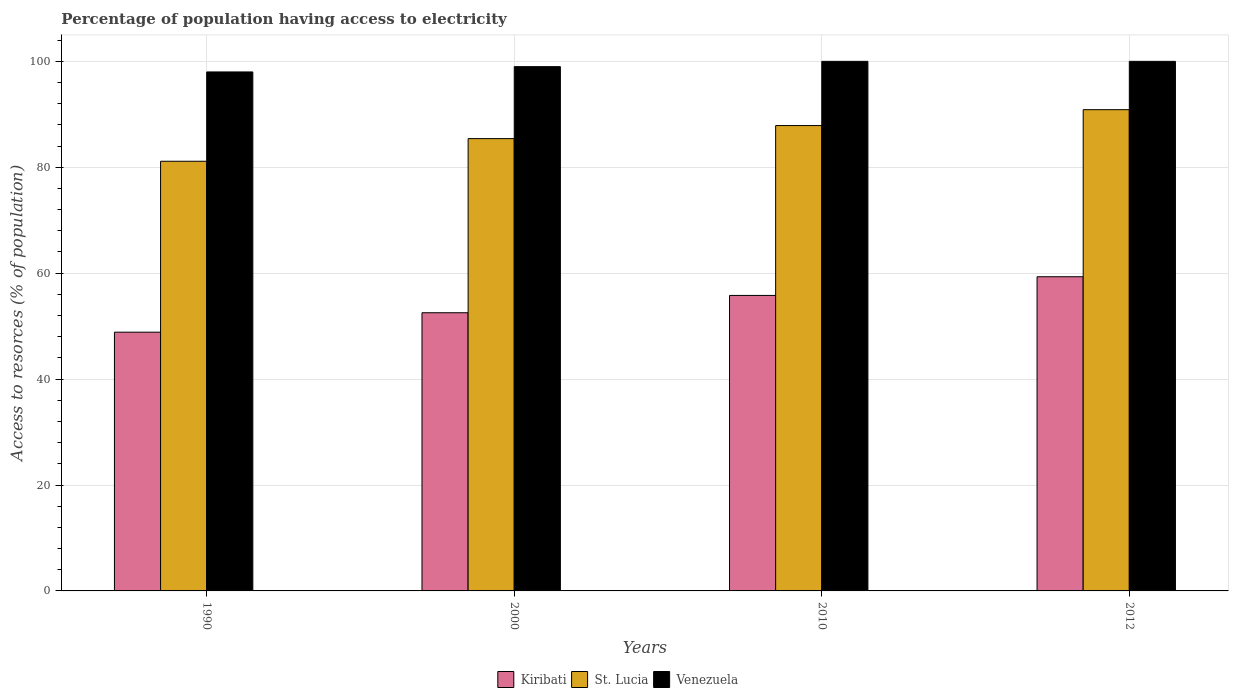How many different coloured bars are there?
Your answer should be compact. 3. How many groups of bars are there?
Your answer should be compact. 4. Are the number of bars on each tick of the X-axis equal?
Give a very brief answer. Yes. How many bars are there on the 4th tick from the left?
Provide a succinct answer. 3. How many bars are there on the 1st tick from the right?
Your answer should be very brief. 3. In how many cases, is the number of bars for a given year not equal to the number of legend labels?
Your answer should be very brief. 0. What is the percentage of population having access to electricity in Kiribati in 2012?
Offer a very short reply. 59.33. Across all years, what is the maximum percentage of population having access to electricity in St. Lucia?
Give a very brief answer. 90.88. Across all years, what is the minimum percentage of population having access to electricity in Venezuela?
Provide a succinct answer. 98. In which year was the percentage of population having access to electricity in Kiribati minimum?
Keep it short and to the point. 1990. What is the total percentage of population having access to electricity in Venezuela in the graph?
Offer a terse response. 397. What is the difference between the percentage of population having access to electricity in Venezuela in 2000 and that in 2010?
Make the answer very short. -1. What is the difference between the percentage of population having access to electricity in Kiribati in 2000 and the percentage of population having access to electricity in St. Lucia in 1990?
Ensure brevity in your answer.  -28.61. What is the average percentage of population having access to electricity in St. Lucia per year?
Provide a succinct answer. 86.32. In the year 2010, what is the difference between the percentage of population having access to electricity in Kiribati and percentage of population having access to electricity in Venezuela?
Provide a succinct answer. -44.2. In how many years, is the percentage of population having access to electricity in Kiribati greater than 88 %?
Your answer should be very brief. 0. What is the ratio of the percentage of population having access to electricity in Kiribati in 2000 to that in 2010?
Your answer should be compact. 0.94. Is the percentage of population having access to electricity in Kiribati in 1990 less than that in 2000?
Your response must be concise. Yes. What is the difference between the highest and the second highest percentage of population having access to electricity in St. Lucia?
Make the answer very short. 3. What is the difference between the highest and the lowest percentage of population having access to electricity in Venezuela?
Your answer should be compact. 2. What does the 3rd bar from the left in 2012 represents?
Your answer should be very brief. Venezuela. What does the 3rd bar from the right in 1990 represents?
Offer a terse response. Kiribati. How many bars are there?
Offer a terse response. 12. Are all the bars in the graph horizontal?
Your answer should be compact. No. How many years are there in the graph?
Ensure brevity in your answer.  4. What is the difference between two consecutive major ticks on the Y-axis?
Ensure brevity in your answer.  20. Are the values on the major ticks of Y-axis written in scientific E-notation?
Keep it short and to the point. No. What is the title of the graph?
Your answer should be very brief. Percentage of population having access to electricity. What is the label or title of the Y-axis?
Your answer should be compact. Access to resorces (% of population). What is the Access to resorces (% of population) in Kiribati in 1990?
Offer a terse response. 48.86. What is the Access to resorces (% of population) in St. Lucia in 1990?
Provide a short and direct response. 81.14. What is the Access to resorces (% of population) in Venezuela in 1990?
Provide a succinct answer. 98. What is the Access to resorces (% of population) of Kiribati in 2000?
Offer a terse response. 52.53. What is the Access to resorces (% of population) in St. Lucia in 2000?
Ensure brevity in your answer.  85.41. What is the Access to resorces (% of population) in Venezuela in 2000?
Your answer should be very brief. 99. What is the Access to resorces (% of population) in Kiribati in 2010?
Make the answer very short. 55.8. What is the Access to resorces (% of population) in St. Lucia in 2010?
Make the answer very short. 87.87. What is the Access to resorces (% of population) of Venezuela in 2010?
Provide a short and direct response. 100. What is the Access to resorces (% of population) in Kiribati in 2012?
Your answer should be compact. 59.33. What is the Access to resorces (% of population) of St. Lucia in 2012?
Your answer should be compact. 90.88. Across all years, what is the maximum Access to resorces (% of population) in Kiribati?
Provide a short and direct response. 59.33. Across all years, what is the maximum Access to resorces (% of population) in St. Lucia?
Your answer should be compact. 90.88. Across all years, what is the minimum Access to resorces (% of population) in Kiribati?
Your answer should be very brief. 48.86. Across all years, what is the minimum Access to resorces (% of population) of St. Lucia?
Give a very brief answer. 81.14. Across all years, what is the minimum Access to resorces (% of population) of Venezuela?
Offer a terse response. 98. What is the total Access to resorces (% of population) of Kiribati in the graph?
Your answer should be very brief. 216.52. What is the total Access to resorces (% of population) in St. Lucia in the graph?
Provide a short and direct response. 345.3. What is the total Access to resorces (% of population) of Venezuela in the graph?
Your answer should be compact. 397. What is the difference between the Access to resorces (% of population) in Kiribati in 1990 and that in 2000?
Make the answer very short. -3.67. What is the difference between the Access to resorces (% of population) in St. Lucia in 1990 and that in 2000?
Offer a very short reply. -4.28. What is the difference between the Access to resorces (% of population) of Venezuela in 1990 and that in 2000?
Provide a short and direct response. -1. What is the difference between the Access to resorces (% of population) of Kiribati in 1990 and that in 2010?
Give a very brief answer. -6.94. What is the difference between the Access to resorces (% of population) of St. Lucia in 1990 and that in 2010?
Make the answer very short. -6.74. What is the difference between the Access to resorces (% of population) of Kiribati in 1990 and that in 2012?
Provide a short and direct response. -10.47. What is the difference between the Access to resorces (% of population) of St. Lucia in 1990 and that in 2012?
Ensure brevity in your answer.  -9.74. What is the difference between the Access to resorces (% of population) of Kiribati in 2000 and that in 2010?
Keep it short and to the point. -3.27. What is the difference between the Access to resorces (% of population) in St. Lucia in 2000 and that in 2010?
Ensure brevity in your answer.  -2.46. What is the difference between the Access to resorces (% of population) of Venezuela in 2000 and that in 2010?
Offer a terse response. -1. What is the difference between the Access to resorces (% of population) of Kiribati in 2000 and that in 2012?
Your response must be concise. -6.8. What is the difference between the Access to resorces (% of population) in St. Lucia in 2000 and that in 2012?
Your answer should be very brief. -5.46. What is the difference between the Access to resorces (% of population) in Kiribati in 2010 and that in 2012?
Provide a succinct answer. -3.53. What is the difference between the Access to resorces (% of population) in St. Lucia in 2010 and that in 2012?
Keep it short and to the point. -3. What is the difference between the Access to resorces (% of population) of Venezuela in 2010 and that in 2012?
Make the answer very short. 0. What is the difference between the Access to resorces (% of population) of Kiribati in 1990 and the Access to resorces (% of population) of St. Lucia in 2000?
Provide a short and direct response. -36.55. What is the difference between the Access to resorces (% of population) in Kiribati in 1990 and the Access to resorces (% of population) in Venezuela in 2000?
Provide a short and direct response. -50.14. What is the difference between the Access to resorces (% of population) of St. Lucia in 1990 and the Access to resorces (% of population) of Venezuela in 2000?
Keep it short and to the point. -17.86. What is the difference between the Access to resorces (% of population) of Kiribati in 1990 and the Access to resorces (% of population) of St. Lucia in 2010?
Provide a succinct answer. -39.01. What is the difference between the Access to resorces (% of population) of Kiribati in 1990 and the Access to resorces (% of population) of Venezuela in 2010?
Your response must be concise. -51.14. What is the difference between the Access to resorces (% of population) in St. Lucia in 1990 and the Access to resorces (% of population) in Venezuela in 2010?
Give a very brief answer. -18.86. What is the difference between the Access to resorces (% of population) in Kiribati in 1990 and the Access to resorces (% of population) in St. Lucia in 2012?
Ensure brevity in your answer.  -42.02. What is the difference between the Access to resorces (% of population) of Kiribati in 1990 and the Access to resorces (% of population) of Venezuela in 2012?
Make the answer very short. -51.14. What is the difference between the Access to resorces (% of population) in St. Lucia in 1990 and the Access to resorces (% of population) in Venezuela in 2012?
Make the answer very short. -18.86. What is the difference between the Access to resorces (% of population) in Kiribati in 2000 and the Access to resorces (% of population) in St. Lucia in 2010?
Provide a short and direct response. -35.34. What is the difference between the Access to resorces (% of population) in Kiribati in 2000 and the Access to resorces (% of population) in Venezuela in 2010?
Your answer should be compact. -47.47. What is the difference between the Access to resorces (% of population) of St. Lucia in 2000 and the Access to resorces (% of population) of Venezuela in 2010?
Your response must be concise. -14.59. What is the difference between the Access to resorces (% of population) of Kiribati in 2000 and the Access to resorces (% of population) of St. Lucia in 2012?
Give a very brief answer. -38.35. What is the difference between the Access to resorces (% of population) in Kiribati in 2000 and the Access to resorces (% of population) in Venezuela in 2012?
Your response must be concise. -47.47. What is the difference between the Access to resorces (% of population) in St. Lucia in 2000 and the Access to resorces (% of population) in Venezuela in 2012?
Provide a short and direct response. -14.59. What is the difference between the Access to resorces (% of population) of Kiribati in 2010 and the Access to resorces (% of population) of St. Lucia in 2012?
Make the answer very short. -35.08. What is the difference between the Access to resorces (% of population) in Kiribati in 2010 and the Access to resorces (% of population) in Venezuela in 2012?
Your response must be concise. -44.2. What is the difference between the Access to resorces (% of population) of St. Lucia in 2010 and the Access to resorces (% of population) of Venezuela in 2012?
Ensure brevity in your answer.  -12.13. What is the average Access to resorces (% of population) in Kiribati per year?
Ensure brevity in your answer.  54.13. What is the average Access to resorces (% of population) of St. Lucia per year?
Provide a short and direct response. 86.32. What is the average Access to resorces (% of population) of Venezuela per year?
Keep it short and to the point. 99.25. In the year 1990, what is the difference between the Access to resorces (% of population) in Kiribati and Access to resorces (% of population) in St. Lucia?
Your answer should be compact. -32.28. In the year 1990, what is the difference between the Access to resorces (% of population) of Kiribati and Access to resorces (% of population) of Venezuela?
Your response must be concise. -49.14. In the year 1990, what is the difference between the Access to resorces (% of population) in St. Lucia and Access to resorces (% of population) in Venezuela?
Your answer should be very brief. -16.86. In the year 2000, what is the difference between the Access to resorces (% of population) of Kiribati and Access to resorces (% of population) of St. Lucia?
Your response must be concise. -32.88. In the year 2000, what is the difference between the Access to resorces (% of population) in Kiribati and Access to resorces (% of population) in Venezuela?
Offer a very short reply. -46.47. In the year 2000, what is the difference between the Access to resorces (% of population) of St. Lucia and Access to resorces (% of population) of Venezuela?
Make the answer very short. -13.59. In the year 2010, what is the difference between the Access to resorces (% of population) of Kiribati and Access to resorces (% of population) of St. Lucia?
Keep it short and to the point. -32.07. In the year 2010, what is the difference between the Access to resorces (% of population) in Kiribati and Access to resorces (% of population) in Venezuela?
Give a very brief answer. -44.2. In the year 2010, what is the difference between the Access to resorces (% of population) in St. Lucia and Access to resorces (% of population) in Venezuela?
Ensure brevity in your answer.  -12.13. In the year 2012, what is the difference between the Access to resorces (% of population) in Kiribati and Access to resorces (% of population) in St. Lucia?
Keep it short and to the point. -31.55. In the year 2012, what is the difference between the Access to resorces (% of population) of Kiribati and Access to resorces (% of population) of Venezuela?
Your answer should be very brief. -40.67. In the year 2012, what is the difference between the Access to resorces (% of population) of St. Lucia and Access to resorces (% of population) of Venezuela?
Keep it short and to the point. -9.12. What is the ratio of the Access to resorces (% of population) of Kiribati in 1990 to that in 2000?
Your response must be concise. 0.93. What is the ratio of the Access to resorces (% of population) in St. Lucia in 1990 to that in 2000?
Provide a short and direct response. 0.95. What is the ratio of the Access to resorces (% of population) of Kiribati in 1990 to that in 2010?
Offer a very short reply. 0.88. What is the ratio of the Access to resorces (% of population) of St. Lucia in 1990 to that in 2010?
Your answer should be very brief. 0.92. What is the ratio of the Access to resorces (% of population) in Venezuela in 1990 to that in 2010?
Your response must be concise. 0.98. What is the ratio of the Access to resorces (% of population) of Kiribati in 1990 to that in 2012?
Your response must be concise. 0.82. What is the ratio of the Access to resorces (% of population) of St. Lucia in 1990 to that in 2012?
Your answer should be compact. 0.89. What is the ratio of the Access to resorces (% of population) in Venezuela in 1990 to that in 2012?
Offer a terse response. 0.98. What is the ratio of the Access to resorces (% of population) of Kiribati in 2000 to that in 2010?
Offer a very short reply. 0.94. What is the ratio of the Access to resorces (% of population) in Venezuela in 2000 to that in 2010?
Your answer should be compact. 0.99. What is the ratio of the Access to resorces (% of population) of Kiribati in 2000 to that in 2012?
Ensure brevity in your answer.  0.89. What is the ratio of the Access to resorces (% of population) in St. Lucia in 2000 to that in 2012?
Your response must be concise. 0.94. What is the ratio of the Access to resorces (% of population) in Venezuela in 2000 to that in 2012?
Offer a very short reply. 0.99. What is the ratio of the Access to resorces (% of population) of Kiribati in 2010 to that in 2012?
Offer a terse response. 0.94. What is the difference between the highest and the second highest Access to resorces (% of population) of Kiribati?
Provide a succinct answer. 3.53. What is the difference between the highest and the second highest Access to resorces (% of population) in St. Lucia?
Offer a very short reply. 3. What is the difference between the highest and the lowest Access to resorces (% of population) in Kiribati?
Your answer should be compact. 10.47. What is the difference between the highest and the lowest Access to resorces (% of population) of St. Lucia?
Your answer should be compact. 9.74. 